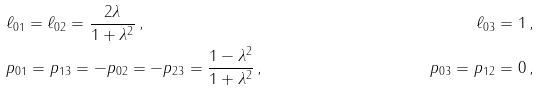Convert formula to latex. <formula><loc_0><loc_0><loc_500><loc_500>& \ell _ { 0 1 } = \ell _ { 0 2 } = \frac { 2 \lambda } { 1 + \lambda ^ { 2 } } \, , & \ell _ { 0 3 } = 1 \, , \\ & p _ { 0 1 } = p _ { 1 3 } = - p _ { 0 2 } = - p _ { 2 3 } = \frac { 1 - \lambda ^ { 2 } } { 1 + \lambda ^ { 2 } } \, , & p _ { 0 3 } = p _ { 1 2 } = 0 \, ,</formula> 